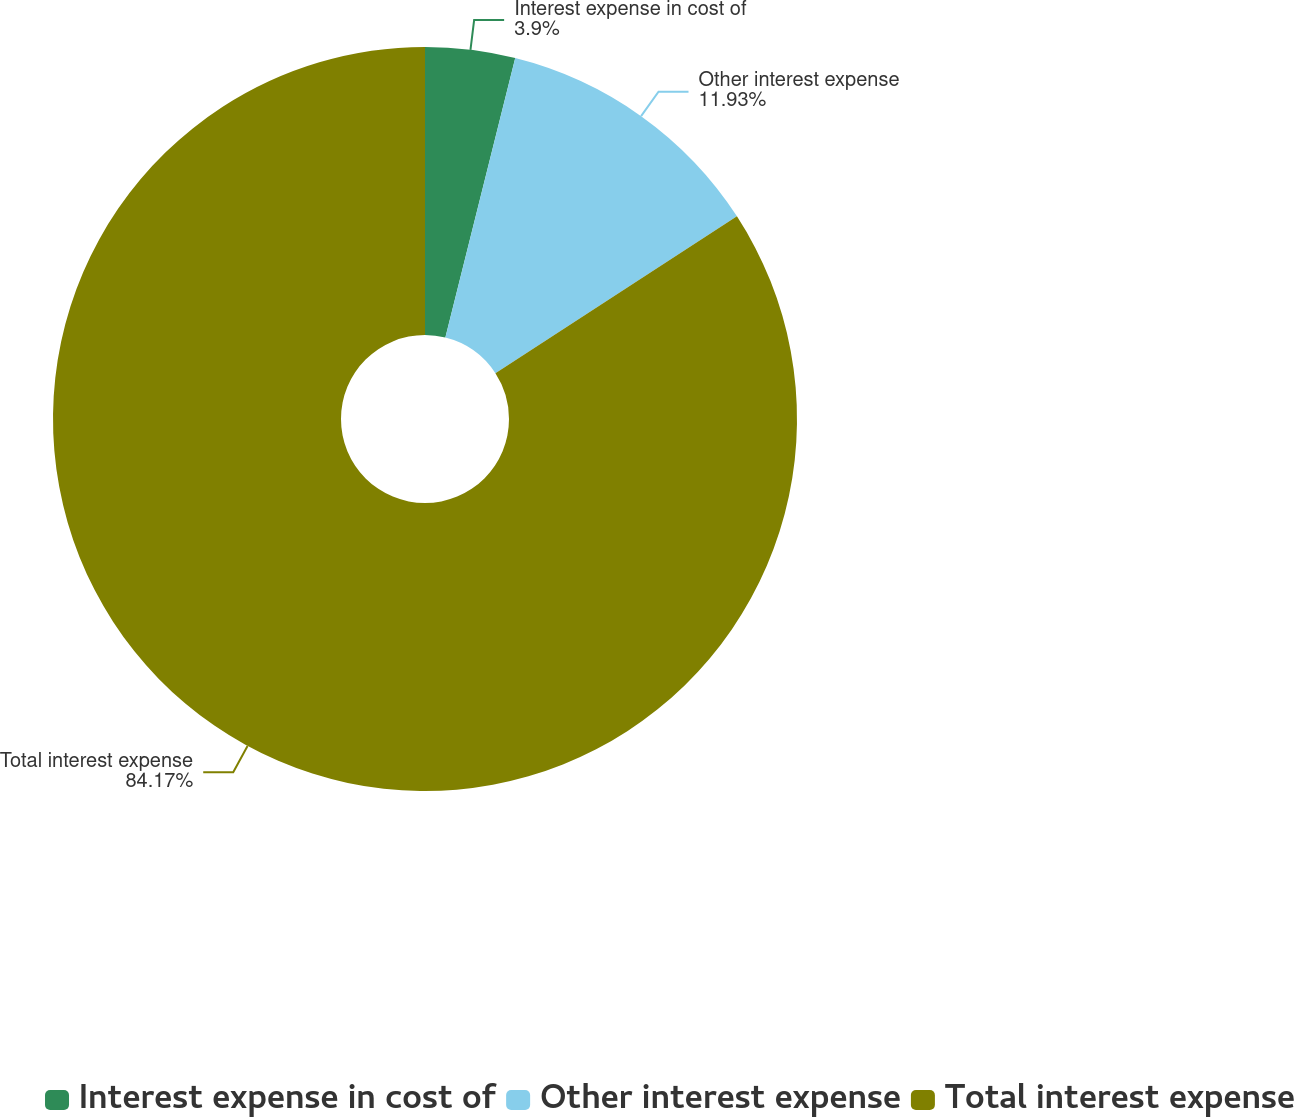Convert chart. <chart><loc_0><loc_0><loc_500><loc_500><pie_chart><fcel>Interest expense in cost of<fcel>Other interest expense<fcel>Total interest expense<nl><fcel>3.9%<fcel>11.93%<fcel>84.17%<nl></chart> 